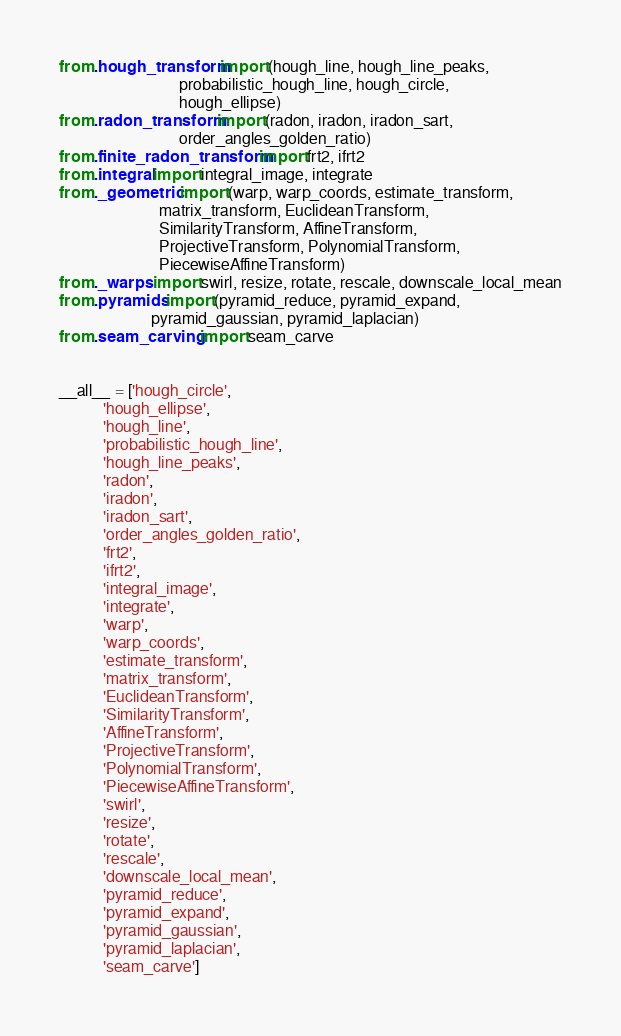<code> <loc_0><loc_0><loc_500><loc_500><_Python_>from .hough_transform import (hough_line, hough_line_peaks,
                              probabilistic_hough_line, hough_circle,
                              hough_ellipse)
from .radon_transform import (radon, iradon, iradon_sart,
                              order_angles_golden_ratio)
from .finite_radon_transform import frt2, ifrt2
from .integral import integral_image, integrate
from ._geometric import (warp, warp_coords, estimate_transform,
                         matrix_transform, EuclideanTransform,
                         SimilarityTransform, AffineTransform,
                         ProjectiveTransform, PolynomialTransform,
                         PiecewiseAffineTransform)
from ._warps import swirl, resize, rotate, rescale, downscale_local_mean
from .pyramids import (pyramid_reduce, pyramid_expand,
                       pyramid_gaussian, pyramid_laplacian)
from .seam_carving import seam_carve


__all__ = ['hough_circle',
           'hough_ellipse',
           'hough_line',
           'probabilistic_hough_line',
           'hough_line_peaks',
           'radon',
           'iradon',
           'iradon_sart',
           'order_angles_golden_ratio',
           'frt2',
           'ifrt2',
           'integral_image',
           'integrate',
           'warp',
           'warp_coords',
           'estimate_transform',
           'matrix_transform',
           'EuclideanTransform',
           'SimilarityTransform',
           'AffineTransform',
           'ProjectiveTransform',
           'PolynomialTransform',
           'PiecewiseAffineTransform',
           'swirl',
           'resize',
           'rotate',
           'rescale',
           'downscale_local_mean',
           'pyramid_reduce',
           'pyramid_expand',
           'pyramid_gaussian',
           'pyramid_laplacian',
           'seam_carve']
</code> 